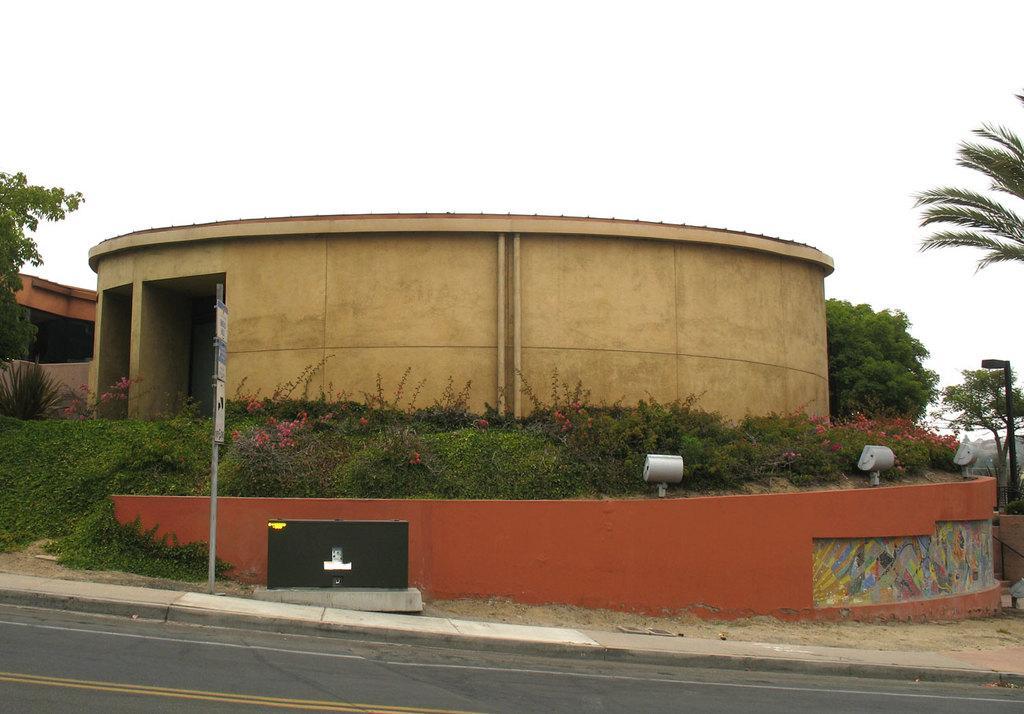In one or two sentences, can you explain what this image depicts? At the bottom of the image there is a road. Behind the road there is a footpath. On the footpath there is a pole with sign boards and also there is a black object. Behind them there is a wall with paintings. And there are bushes with flowers. And also there is a building with walls and pillars. On the left and right side corner of the image there are trees. At the top of the image there is sky. 